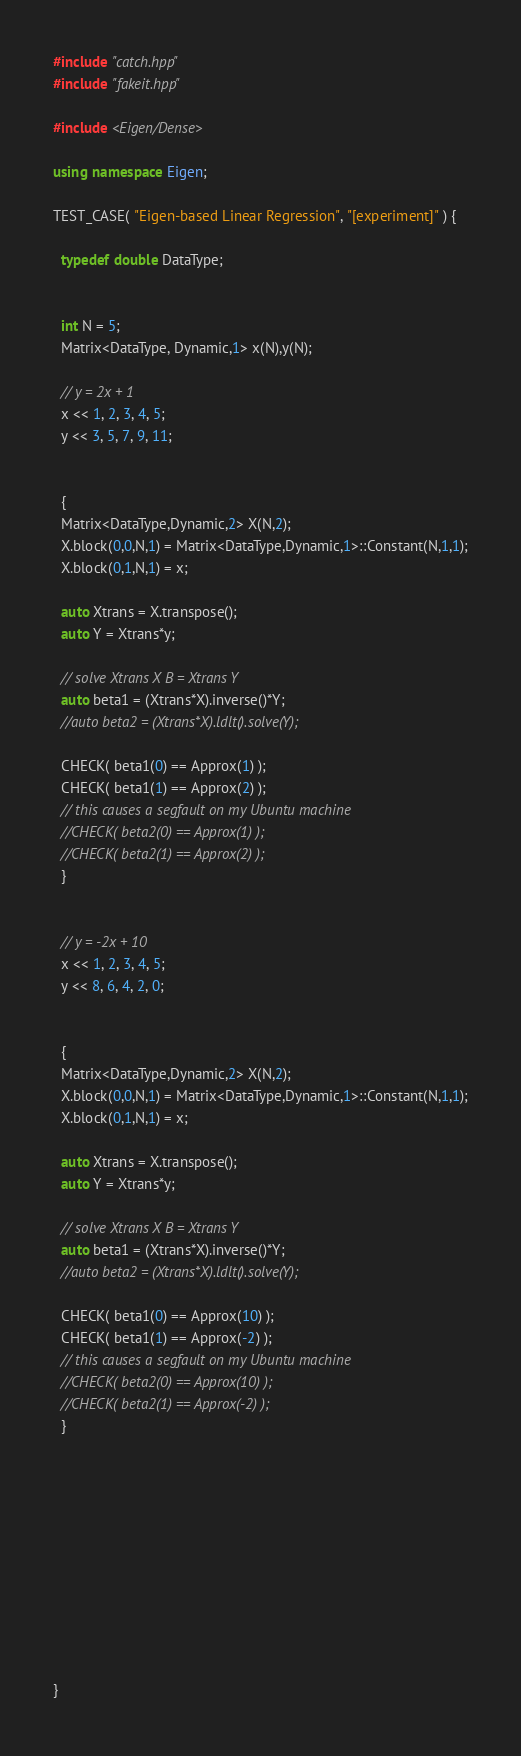<code> <loc_0><loc_0><loc_500><loc_500><_C++_>#include "catch.hpp"
#include "fakeit.hpp"

#include <Eigen/Dense>

using namespace Eigen;

TEST_CASE( "Eigen-based Linear Regression", "[experiment]" ) {

  typedef double DataType;


  int N = 5;
  Matrix<DataType, Dynamic,1> x(N),y(N);

  // y = 2x + 1
  x << 1, 2, 3, 4, 5;
  y << 3, 5, 7, 9, 11;


  {
  Matrix<DataType,Dynamic,2> X(N,2);
  X.block(0,0,N,1) = Matrix<DataType,Dynamic,1>::Constant(N,1,1);
  X.block(0,1,N,1) = x;

  auto Xtrans = X.transpose();
  auto Y = Xtrans*y;

  // solve Xtrans X B = Xtrans Y
  auto beta1 = (Xtrans*X).inverse()*Y;
  //auto beta2 = (Xtrans*X).ldlt().solve(Y);

  CHECK( beta1(0) == Approx(1) );
  CHECK( beta1(1) == Approx(2) );
  // this causes a segfault on my Ubuntu machine
  //CHECK( beta2(0) == Approx(1) );
  //CHECK( beta2(1) == Approx(2) );
  }


  // y = -2x + 10
  x << 1, 2, 3, 4, 5;
  y << 8, 6, 4, 2, 0;


  {
  Matrix<DataType,Dynamic,2> X(N,2);
  X.block(0,0,N,1) = Matrix<DataType,Dynamic,1>::Constant(N,1,1);
  X.block(0,1,N,1) = x;

  auto Xtrans = X.transpose();
  auto Y = Xtrans*y;

  // solve Xtrans X B = Xtrans Y
  auto beta1 = (Xtrans*X).inverse()*Y;
  //auto beta2 = (Xtrans*X).ldlt().solve(Y);

  CHECK( beta1(0) == Approx(10) );
  CHECK( beta1(1) == Approx(-2) );
  // this causes a segfault on my Ubuntu machine
  //CHECK( beta2(0) == Approx(10) );
  //CHECK( beta2(1) == Approx(-2) );
  }











}
</code> 